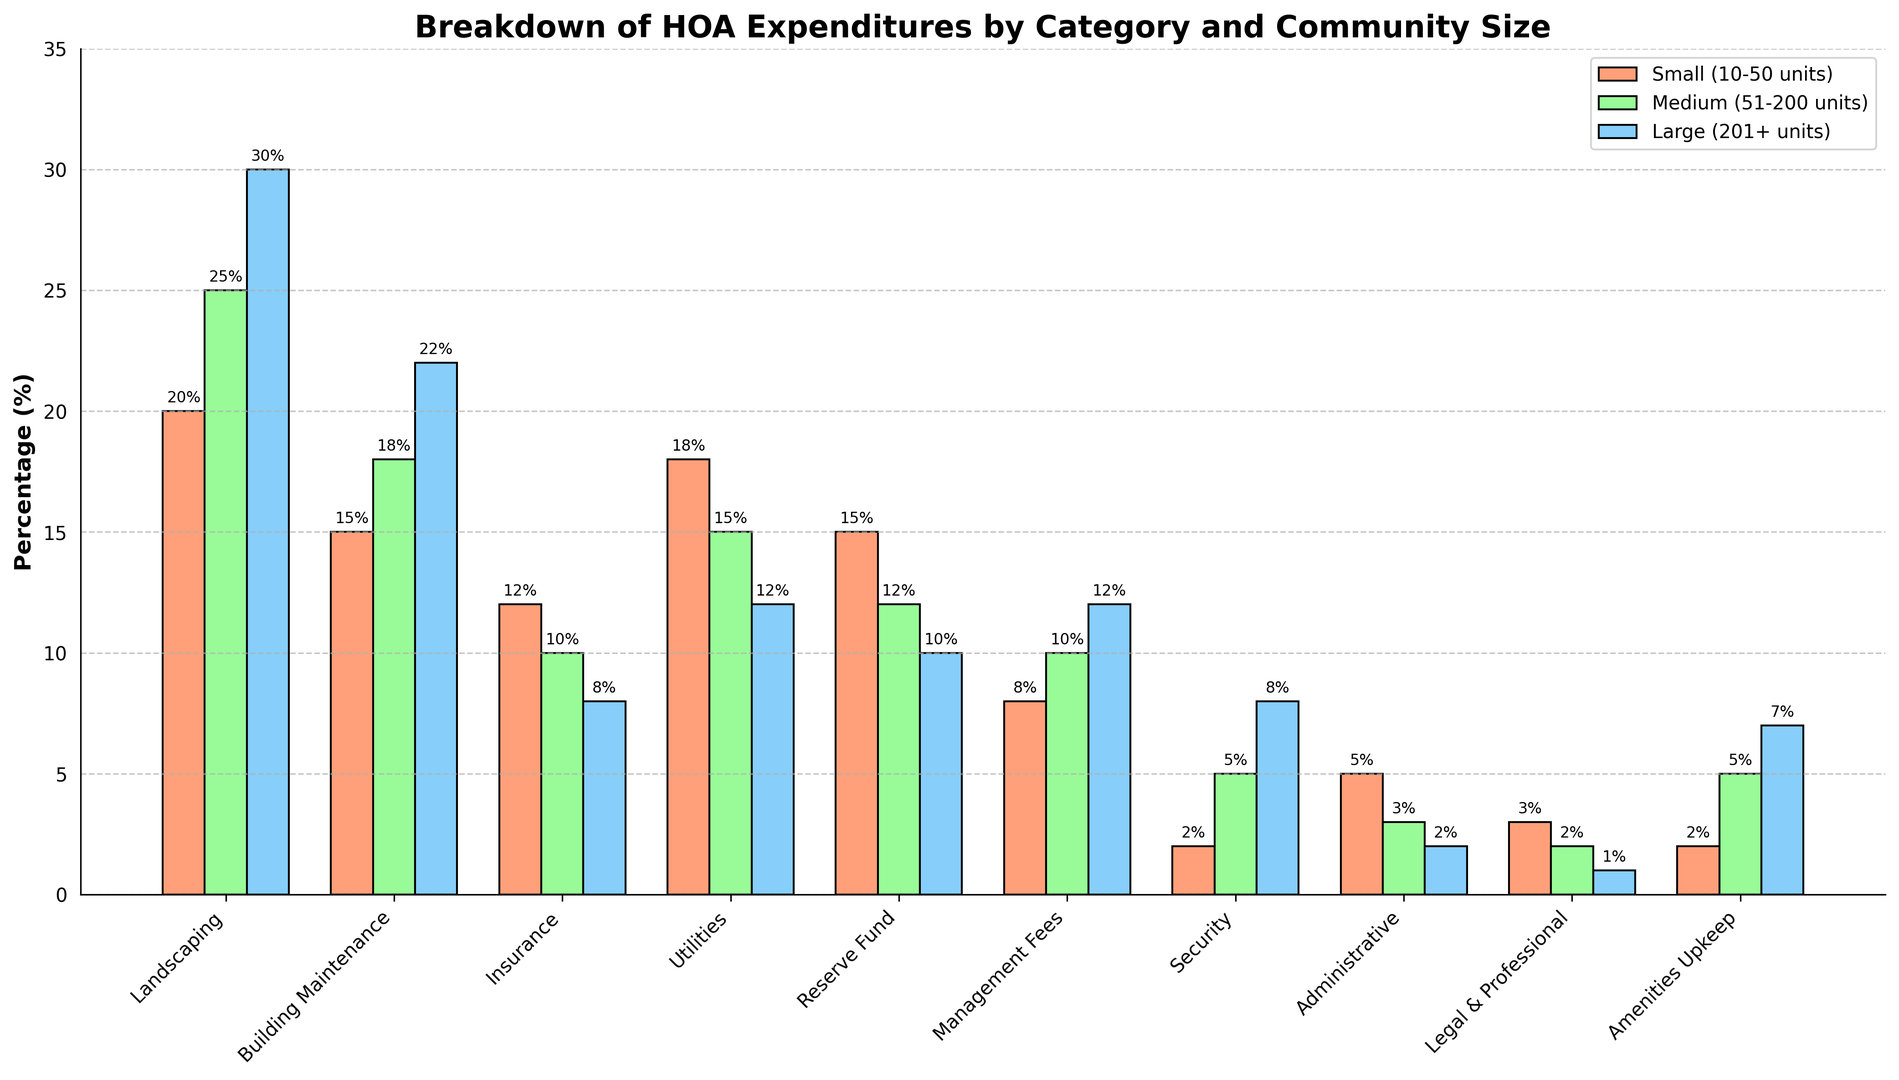Which category has the highest expenditure for large communities? The tallest bar within the 'Large Communities (201+ units)' group represents the highest expenditure. By visual inspection, the 'Landscaping' category bar is the tallest at 30%.
Answer: Landscaping What is the combined percentage of expenditures on 'Insurance' and 'Utilities' for small communities? To find the combined percentage, sum the 'Insurance' and 'Utilities' values for small communities: 'Insurance' is 12% and 'Utilities' is 18%. Thus, 12 + 18 = 30.
Answer: 30% Which community size spends more on 'Security': small or medium communities? Compare the heights of the bars in the 'Security' category for small and medium communities. The bar for small communities is at 2%, and for medium communities, it's at 5%.
Answer: Medium communities Among all the categories, which one has the least expenditure for medium communities? Identify the shortest bar in the medium communities group. The shortest bar is in the 'Legal & Professional' category at 2%.
Answer: Legal & Professional How much more do large communities spend on 'Building Maintenance' compared to small communities? Subtract the 'Building Maintenance' expenditure for small communities (15%) from the expenditure for large communities (22%): 22 - 15 = 7.
Answer: 7% In small communities, which category apart from 'Landscaping' has the highest expenditure? Exclude the 'Landscaping' category and identify the next tallest bar in the small communities group. The 'Utilities' category bar is at 18%.
Answer: Utilities What is the average expenditure on 'Amenities Upkeep' across all community sizes? Calculate the average of the 'Amenities Upkeep' values: (2% from small, 5% from medium, and 7% from large communities). Average = (2 + 5 + 7) / 3 = 4.67.
Answer: 4.67% What percentage of total expenditures do small communities allocate to 'Administrative' and 'Management Fees'? Sum the expenditures for 'Administrative' (5%) and 'Management Fees' (8%) in small communities: 5 + 8 = 13.
Answer: 13% For which category is the difference in expenditures between small and large communities the greatest? Calculate the absolute differences for each category between small and large communities and identify the maximum: 
- Landscaping: 30-20 = 10 
- Building Maintenance: 22-15 = 7 
- Insurance: 12-8 = 4 
- Utilities: 18-12 = 6 
- Reserve Fund: 15-10 = 5 
- Management Fees: 12-8 = 4 
- Security: 8-2 = 6 
- Administrative: 5-2 = 3 
- Legal & Professional: 3-1 = 2 
- Amenities Upkeep: 7-2 = 5 
The greatest difference is in 'Landscaping' with a difference of 10.
Answer: Landscaping 